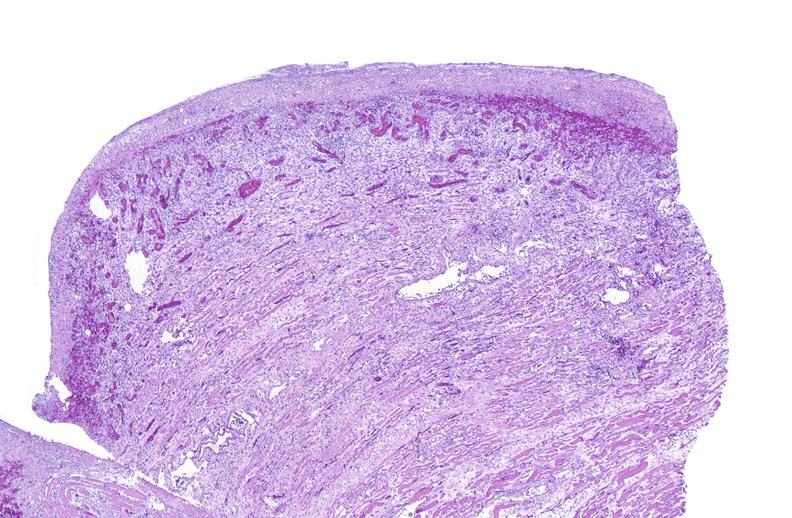s muscle present?
Answer the question using a single word or phrase. Yes 